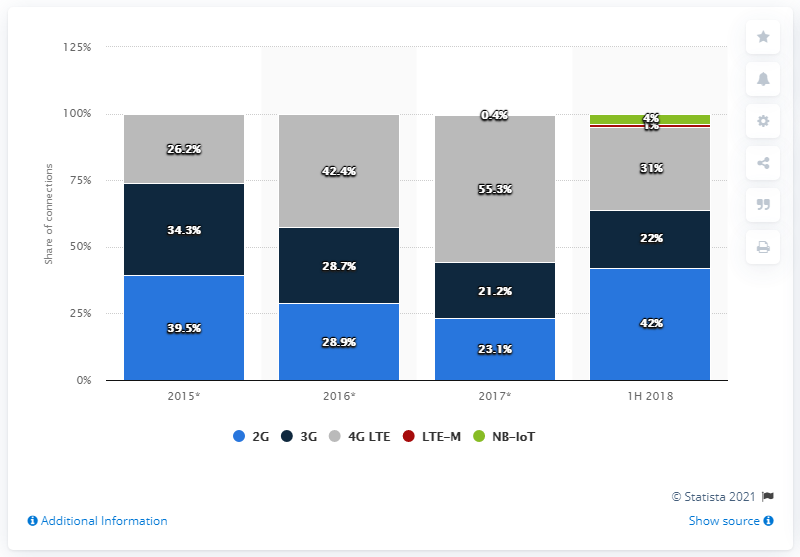Outline some significant characteristics in this image. During the first half of 2018, 31% of global cellular IoT connections were 4G LTE connections. In the first half of 2018, 4G LTE accounted for 31% of global cellular IoT connections, making it the dominant technology in this field. 